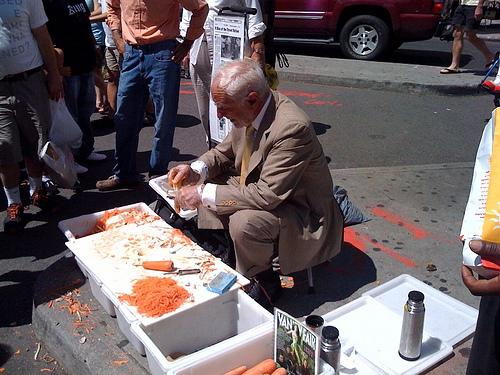What is the orange item? Please explain your reasoning. carrot. The orange item is a root vegetable. 